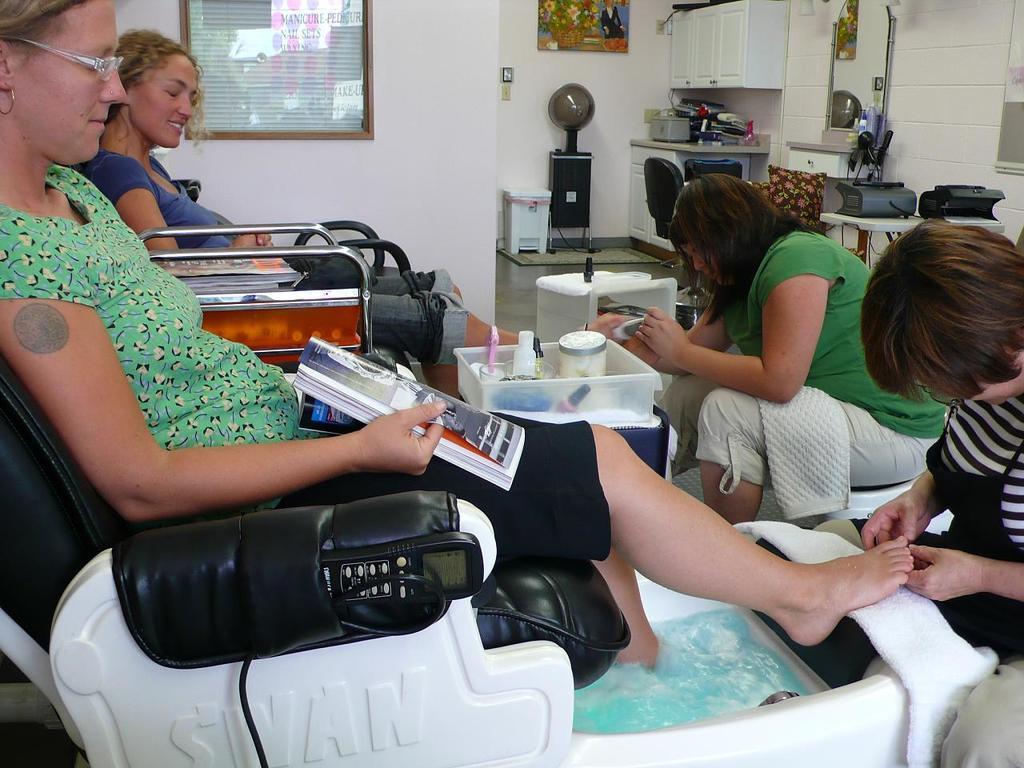Can you describe this image briefly? There are two women sitting on the chairs we can see on the left side of this image, and there are two persons sitting on the right side of this image. There is a wall in the background, and there is a photo frame attached to this wall. We can see some objects are present on the right side of this image. 